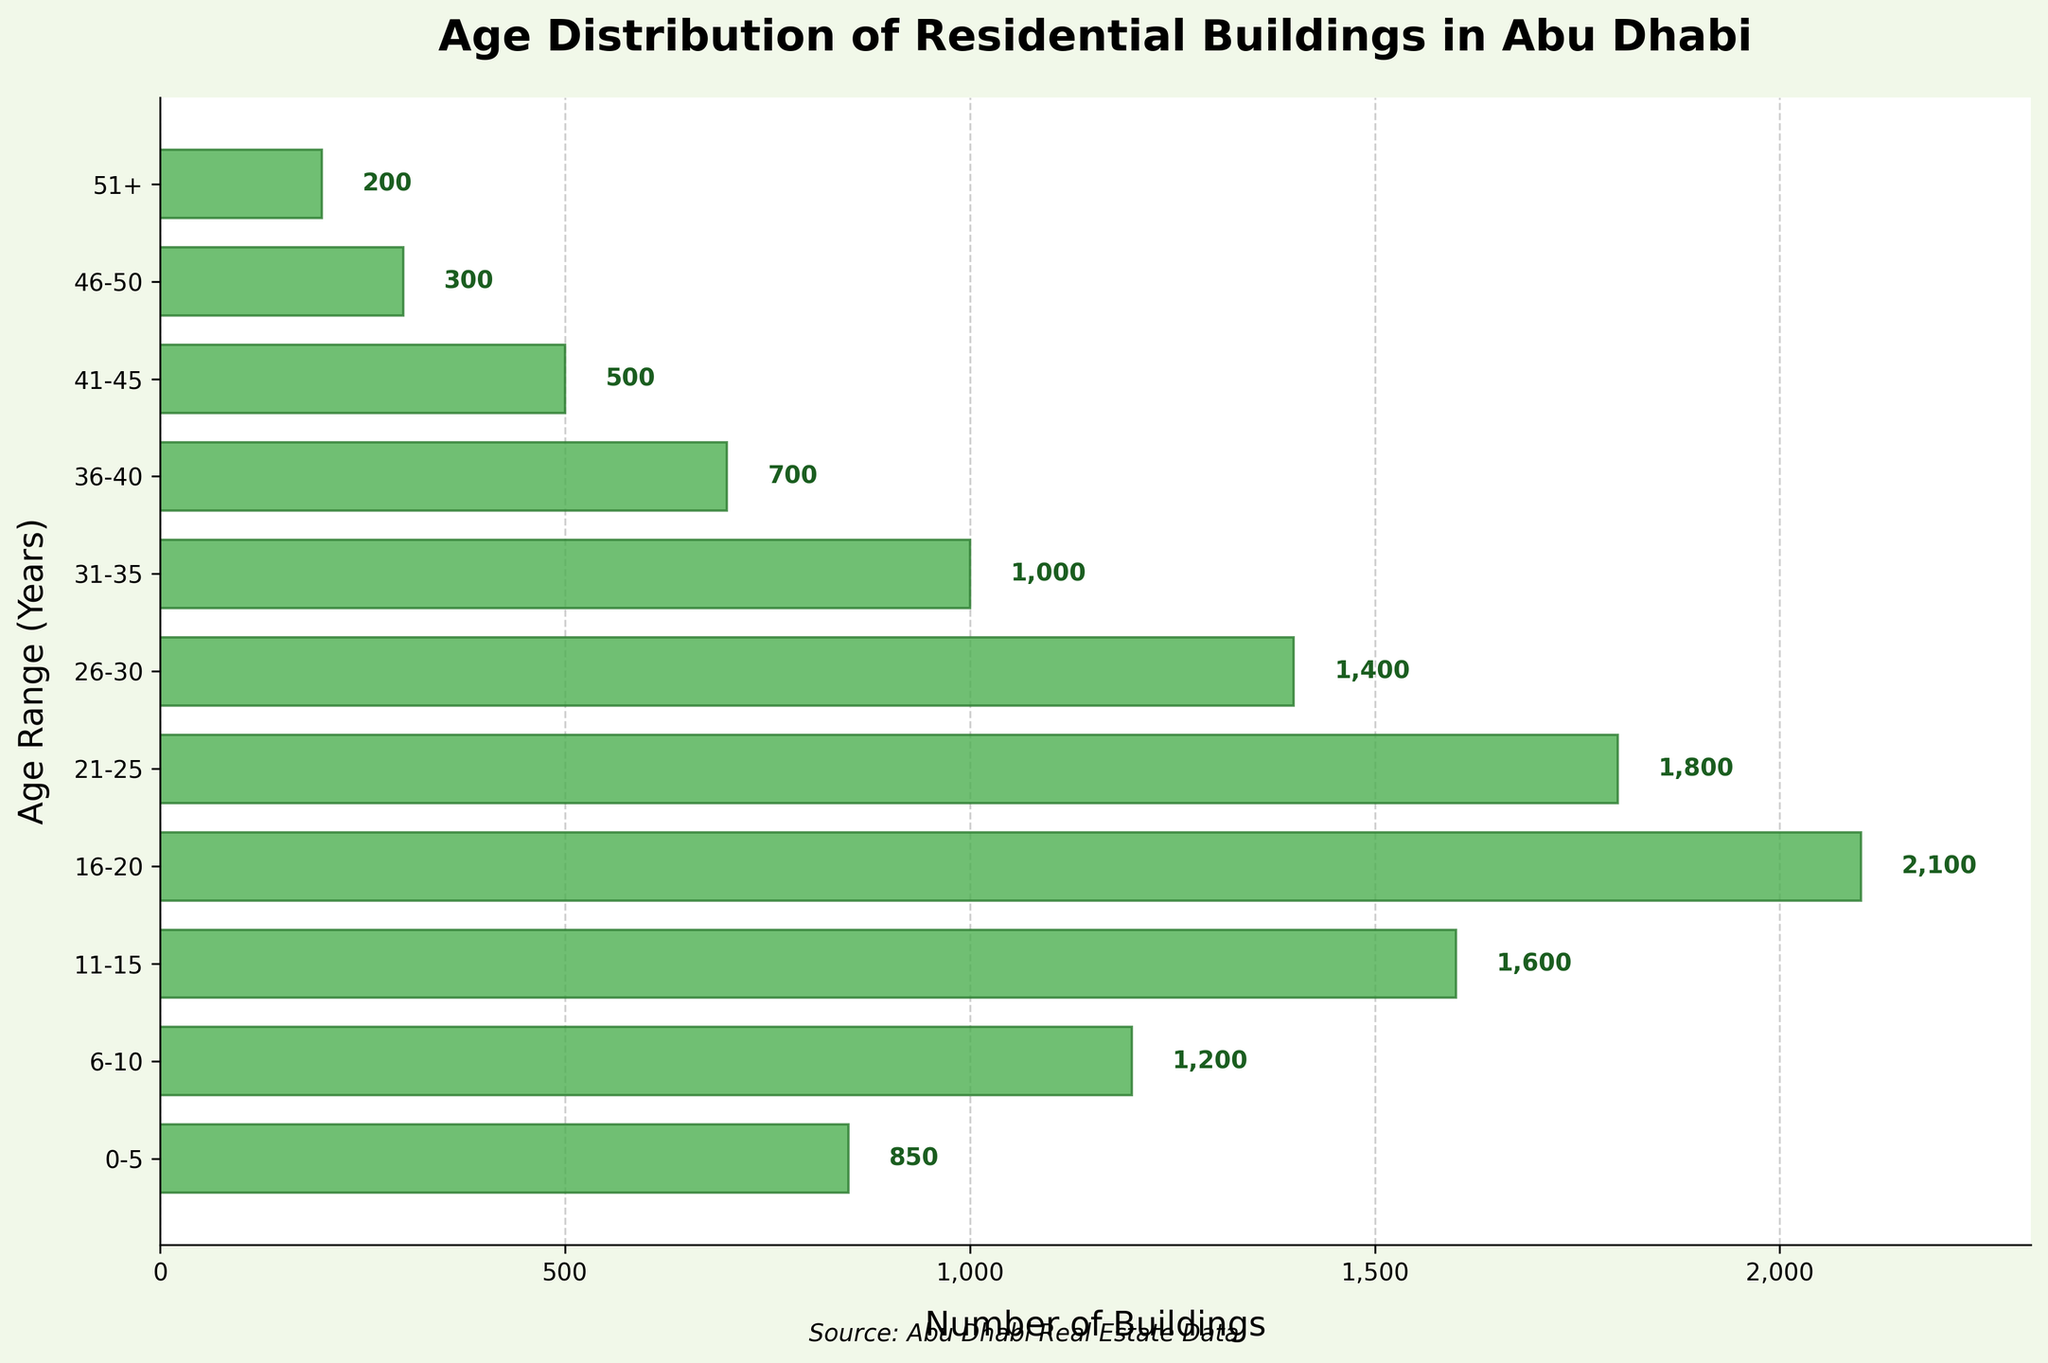What is the title of the plot? The title of the plot is prominently displayed at the top and reads "Age Distribution of Residential Buildings in Abu Dhabi".
Answer: Age Distribution of Residential Buildings in Abu Dhabi What is the age range with the highest number of buildings? The bars represent the number of buildings in different age ranges. The age range with the tallest bar has the highest building count. The tallest bar is for the 16-20 age range.
Answer: 16-20 What is the range of the x-axis? The x-axis indicates the number of buildings and ranges from 0 to a bit more than 2000, as adjusted for clarity. This range is defined by the length of the horizontal bars.
Answer: 0 to ~2000 How many buildings are 26-30 years old? The horizontal bar corresponding to the 26-30 age range shows the number of buildings, and the value on the bar is labeled. According to the label, it is 1400 buildings.
Answer: 1400 Which age groups have fewer than 500 buildings? By examining the horizontal bars with values under 500, the age ranges with a corresponding number of buildings less than 500 are identifiable. These are the 41-45 (500 exactly but should be considered) and the 46-50 (300) and 51+ (200) age ranges.
Answer: 41-45, 46-50, 51+ What is the difference in the number of buildings between the 21-25 and 0-5 age ranges? Referring to the labeled values on the bars, the 21-25 age range has 1800 buildings, and the 0-5 age range has 850 buildings. The difference is calculated by subtracting 850 from 1800.
Answer: 950 What is the total number of buildings for age ranges 31-35 and 36-40? Sum the labeled values on the bars for 31-35 (1000) and 36-40 (700). Adding these gives 1000 + 700.
Answer: 1700 Which age range has twice (or approximately twice) as many buildings as the 11-15 age range? The 11-15 age range has 1600 buildings. Identify any age range with bars showing double this count. None meet exactly twice, but the 16-20 age range is close with 2100. It’s the closest in comparison.
Answer: 16-20 What is the color of the bars in the plot? The bars in the horizontal density plot are all colored in the same shade of green. The consistent color is used to represent each age range clearly and uniformly.
Answer: Green 